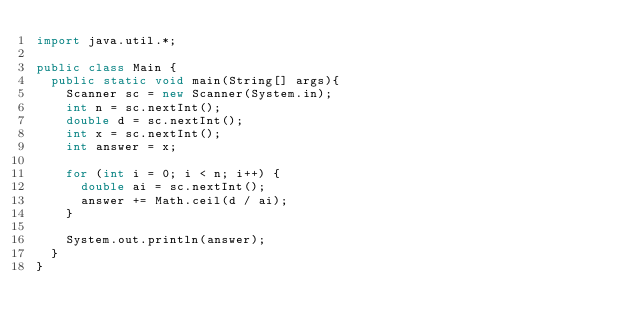Convert code to text. <code><loc_0><loc_0><loc_500><loc_500><_Java_>import java.util.*;

public class Main {
	public static void main(String[] args){
    Scanner sc = new Scanner(System.in);
	 	int n = sc.nextInt();
		double d = sc.nextInt();
		int x = sc.nextInt();
		int answer = x;

		for (int i = 0; i < n; i++) {
			double ai = sc.nextInt();
			answer += Math.ceil(d / ai);
		}

		System.out.println(answer);
  }
}
</code> 